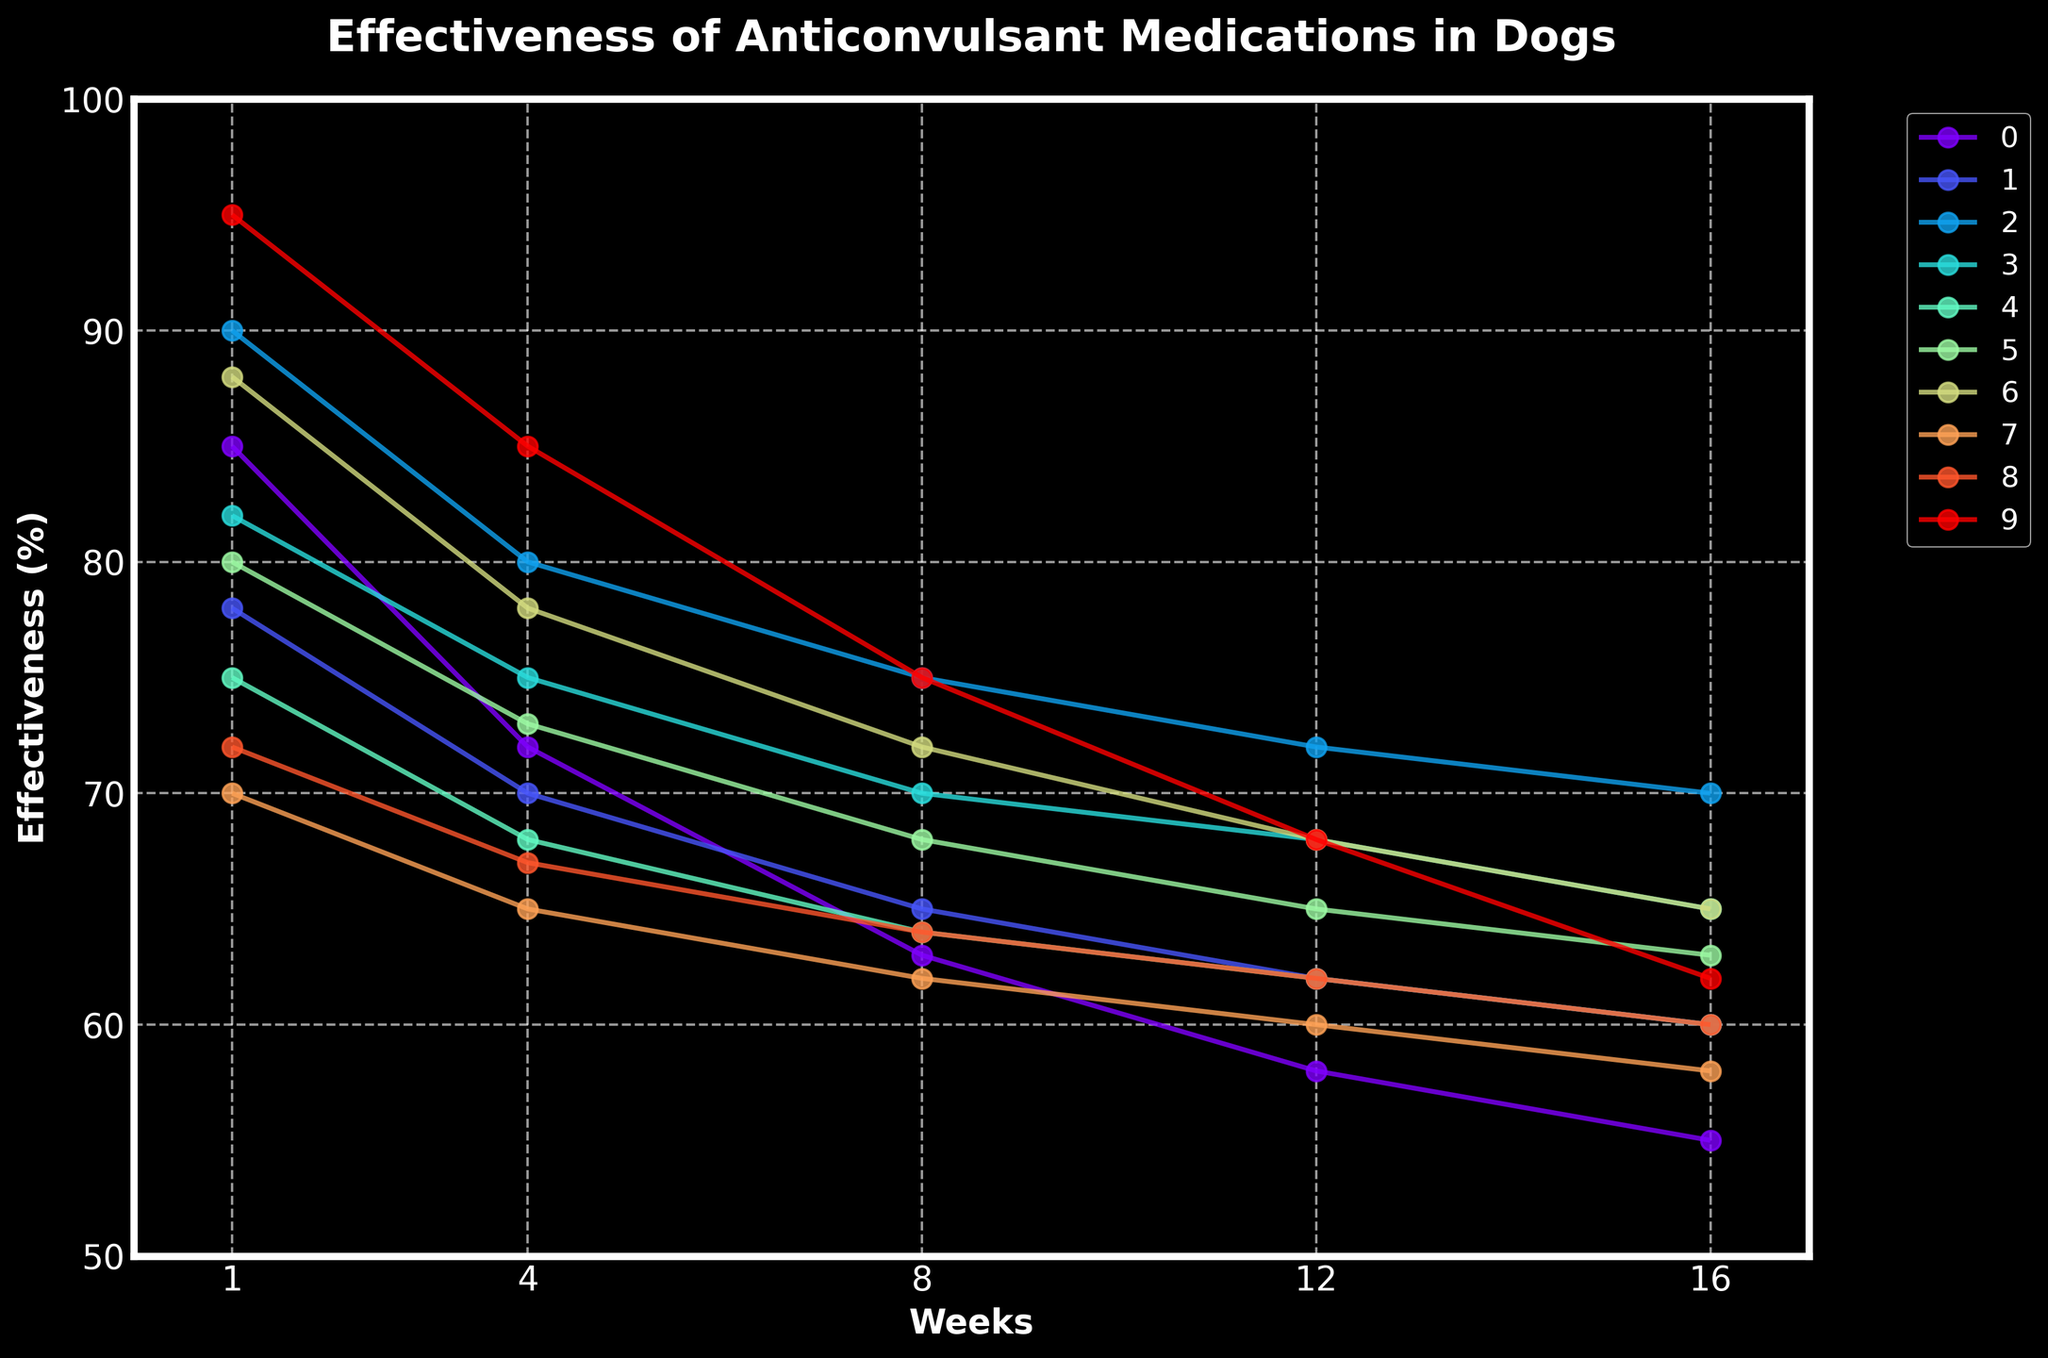Which medication shows the highest effectiveness in Week 1? Look at the data points for Week 1 and identify the highest value; Diazepam has the highest effectiveness at 95%.
Answer: Diazepam Comparing Week 1 and Week 16, which medication shows the largest reduction in effectiveness? Calculate the reduction for each medication by subtracting the Week 16 value from the Week 1 value; Diazepam shows the largest reduction from 95% to 62%, a decrease of 33%.
Answer: Diazepam Which two medications have the closest effectiveness values in Week 8? Compare the values of all medications in Week 8 and find the two with the smallest difference; Gabapentin and Clorazepate are both 64%.
Answer: Gabapentin and Clorazepate What's the average effectiveness of Phenobarbital over the entire period? Add the effectiveness values of Phenobarbital for all weeks and divide by the number of weeks (85+72+63+58+55)/5 = 66.6%
Answer: 66.6% Which medication shows the most consistent effectiveness trend over time? Observe the plots for all medications to see which has the smoothest and least variable trend; Potassium Bromide has a relatively smooth decrease.
Answer: Potassium Bromide In Week 12, are there any medications with the same effectiveness percentage? Compare the effectiveness values of all medications in Week 12; Gabapentin and Clorazepate both have 62%.
Answer: Gabapentin and Clorazepate Which medication has the second highest effectiveness by Week 16? List the effectiveness values at Week 16 and identify the second highest; Phenobarbital is highest at 55%, followed by Levetiracetam at 70%.
Answer: Levetiracetam Between Weeks 8 and 12, which medication's effectiveness shows the least decrease in percentage? Calculate the difference in effectiveness between Weeks 8 and 12 for each medication; Diazepam decreases the least from 75% to 68%, a 7% decrease.
Answer: Diazepam 